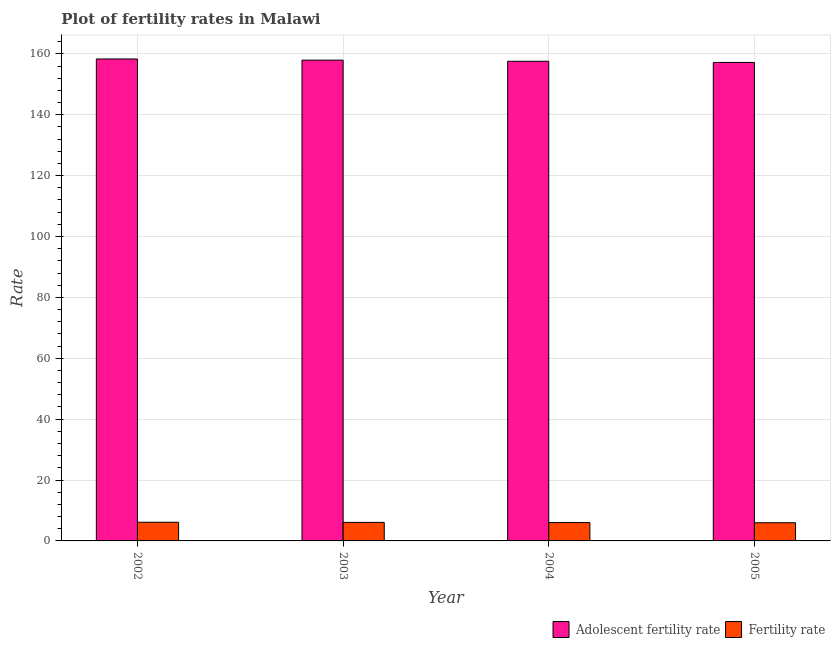How many groups of bars are there?
Your response must be concise. 4. How many bars are there on the 1st tick from the left?
Offer a very short reply. 2. What is the label of the 1st group of bars from the left?
Provide a succinct answer. 2002. What is the fertility rate in 2002?
Offer a terse response. 6.14. Across all years, what is the maximum fertility rate?
Give a very brief answer. 6.14. Across all years, what is the minimum fertility rate?
Offer a terse response. 5.97. What is the total adolescent fertility rate in the graph?
Your answer should be compact. 630.96. What is the difference between the adolescent fertility rate in 2002 and that in 2005?
Your answer should be compact. 1.14. What is the difference between the adolescent fertility rate in 2005 and the fertility rate in 2004?
Ensure brevity in your answer.  -0.38. What is the average fertility rate per year?
Keep it short and to the point. 6.05. In the year 2002, what is the difference between the fertility rate and adolescent fertility rate?
Ensure brevity in your answer.  0. What is the ratio of the fertility rate in 2002 to that in 2004?
Keep it short and to the point. 1.02. What is the difference between the highest and the second highest adolescent fertility rate?
Keep it short and to the point. 0.38. What is the difference between the highest and the lowest adolescent fertility rate?
Make the answer very short. 1.14. Is the sum of the adolescent fertility rate in 2002 and 2005 greater than the maximum fertility rate across all years?
Your response must be concise. Yes. What does the 2nd bar from the left in 2003 represents?
Your response must be concise. Fertility rate. What does the 2nd bar from the right in 2005 represents?
Your answer should be very brief. Adolescent fertility rate. How many bars are there?
Your answer should be compact. 8. Are all the bars in the graph horizontal?
Ensure brevity in your answer.  No. What is the difference between two consecutive major ticks on the Y-axis?
Ensure brevity in your answer.  20. Are the values on the major ticks of Y-axis written in scientific E-notation?
Your answer should be compact. No. Where does the legend appear in the graph?
Give a very brief answer. Bottom right. How many legend labels are there?
Your answer should be compact. 2. How are the legend labels stacked?
Your answer should be very brief. Horizontal. What is the title of the graph?
Your response must be concise. Plot of fertility rates in Malawi. What is the label or title of the X-axis?
Your response must be concise. Year. What is the label or title of the Y-axis?
Ensure brevity in your answer.  Rate. What is the Rate in Adolescent fertility rate in 2002?
Give a very brief answer. 158.31. What is the Rate in Fertility rate in 2002?
Your response must be concise. 6.14. What is the Rate of Adolescent fertility rate in 2003?
Ensure brevity in your answer.  157.93. What is the Rate of Fertility rate in 2003?
Provide a succinct answer. 6.08. What is the Rate of Adolescent fertility rate in 2004?
Your answer should be very brief. 157.55. What is the Rate in Fertility rate in 2004?
Offer a terse response. 6.03. What is the Rate of Adolescent fertility rate in 2005?
Provide a short and direct response. 157.17. What is the Rate in Fertility rate in 2005?
Keep it short and to the point. 5.97. Across all years, what is the maximum Rate of Adolescent fertility rate?
Your answer should be very brief. 158.31. Across all years, what is the maximum Rate in Fertility rate?
Your answer should be compact. 6.14. Across all years, what is the minimum Rate in Adolescent fertility rate?
Your answer should be compact. 157.17. Across all years, what is the minimum Rate in Fertility rate?
Your response must be concise. 5.97. What is the total Rate in Adolescent fertility rate in the graph?
Your answer should be compact. 630.96. What is the total Rate of Fertility rate in the graph?
Your answer should be compact. 24.22. What is the difference between the Rate in Adolescent fertility rate in 2002 and that in 2003?
Make the answer very short. 0.38. What is the difference between the Rate in Fertility rate in 2002 and that in 2003?
Ensure brevity in your answer.  0.06. What is the difference between the Rate in Adolescent fertility rate in 2002 and that in 2004?
Your response must be concise. 0.76. What is the difference between the Rate in Fertility rate in 2002 and that in 2004?
Make the answer very short. 0.11. What is the difference between the Rate of Adolescent fertility rate in 2002 and that in 2005?
Provide a succinct answer. 1.14. What is the difference between the Rate in Fertility rate in 2002 and that in 2005?
Your answer should be compact. 0.17. What is the difference between the Rate of Adolescent fertility rate in 2003 and that in 2004?
Offer a very short reply. 0.38. What is the difference between the Rate of Fertility rate in 2003 and that in 2004?
Give a very brief answer. 0.06. What is the difference between the Rate in Adolescent fertility rate in 2003 and that in 2005?
Offer a terse response. 0.76. What is the difference between the Rate of Fertility rate in 2003 and that in 2005?
Offer a terse response. 0.11. What is the difference between the Rate of Adolescent fertility rate in 2004 and that in 2005?
Your answer should be compact. 0.38. What is the difference between the Rate of Fertility rate in 2004 and that in 2005?
Your response must be concise. 0.06. What is the difference between the Rate in Adolescent fertility rate in 2002 and the Rate in Fertility rate in 2003?
Give a very brief answer. 152.23. What is the difference between the Rate of Adolescent fertility rate in 2002 and the Rate of Fertility rate in 2004?
Ensure brevity in your answer.  152.28. What is the difference between the Rate of Adolescent fertility rate in 2002 and the Rate of Fertility rate in 2005?
Provide a succinct answer. 152.34. What is the difference between the Rate of Adolescent fertility rate in 2003 and the Rate of Fertility rate in 2004?
Your answer should be compact. 151.9. What is the difference between the Rate of Adolescent fertility rate in 2003 and the Rate of Fertility rate in 2005?
Your answer should be very brief. 151.96. What is the difference between the Rate in Adolescent fertility rate in 2004 and the Rate in Fertility rate in 2005?
Provide a succinct answer. 151.58. What is the average Rate of Adolescent fertility rate per year?
Provide a succinct answer. 157.74. What is the average Rate in Fertility rate per year?
Offer a very short reply. 6.05. In the year 2002, what is the difference between the Rate of Adolescent fertility rate and Rate of Fertility rate?
Make the answer very short. 152.17. In the year 2003, what is the difference between the Rate in Adolescent fertility rate and Rate in Fertility rate?
Provide a succinct answer. 151.85. In the year 2004, what is the difference between the Rate of Adolescent fertility rate and Rate of Fertility rate?
Provide a short and direct response. 151.52. In the year 2005, what is the difference between the Rate of Adolescent fertility rate and Rate of Fertility rate?
Keep it short and to the point. 151.2. What is the ratio of the Rate of Adolescent fertility rate in 2002 to that in 2003?
Make the answer very short. 1. What is the ratio of the Rate in Fertility rate in 2002 to that in 2003?
Offer a terse response. 1.01. What is the ratio of the Rate of Fertility rate in 2002 to that in 2004?
Ensure brevity in your answer.  1.02. What is the ratio of the Rate of Adolescent fertility rate in 2002 to that in 2005?
Your response must be concise. 1.01. What is the ratio of the Rate in Fertility rate in 2002 to that in 2005?
Provide a succinct answer. 1.03. What is the ratio of the Rate in Adolescent fertility rate in 2003 to that in 2004?
Your answer should be very brief. 1. What is the ratio of the Rate in Fertility rate in 2003 to that in 2004?
Offer a terse response. 1.01. What is the ratio of the Rate of Adolescent fertility rate in 2003 to that in 2005?
Your answer should be very brief. 1. What is the ratio of the Rate in Fertility rate in 2003 to that in 2005?
Ensure brevity in your answer.  1.02. What is the ratio of the Rate in Fertility rate in 2004 to that in 2005?
Keep it short and to the point. 1.01. What is the difference between the highest and the second highest Rate of Adolescent fertility rate?
Keep it short and to the point. 0.38. What is the difference between the highest and the second highest Rate of Fertility rate?
Your answer should be very brief. 0.06. What is the difference between the highest and the lowest Rate in Adolescent fertility rate?
Give a very brief answer. 1.14. What is the difference between the highest and the lowest Rate in Fertility rate?
Your answer should be very brief. 0.17. 